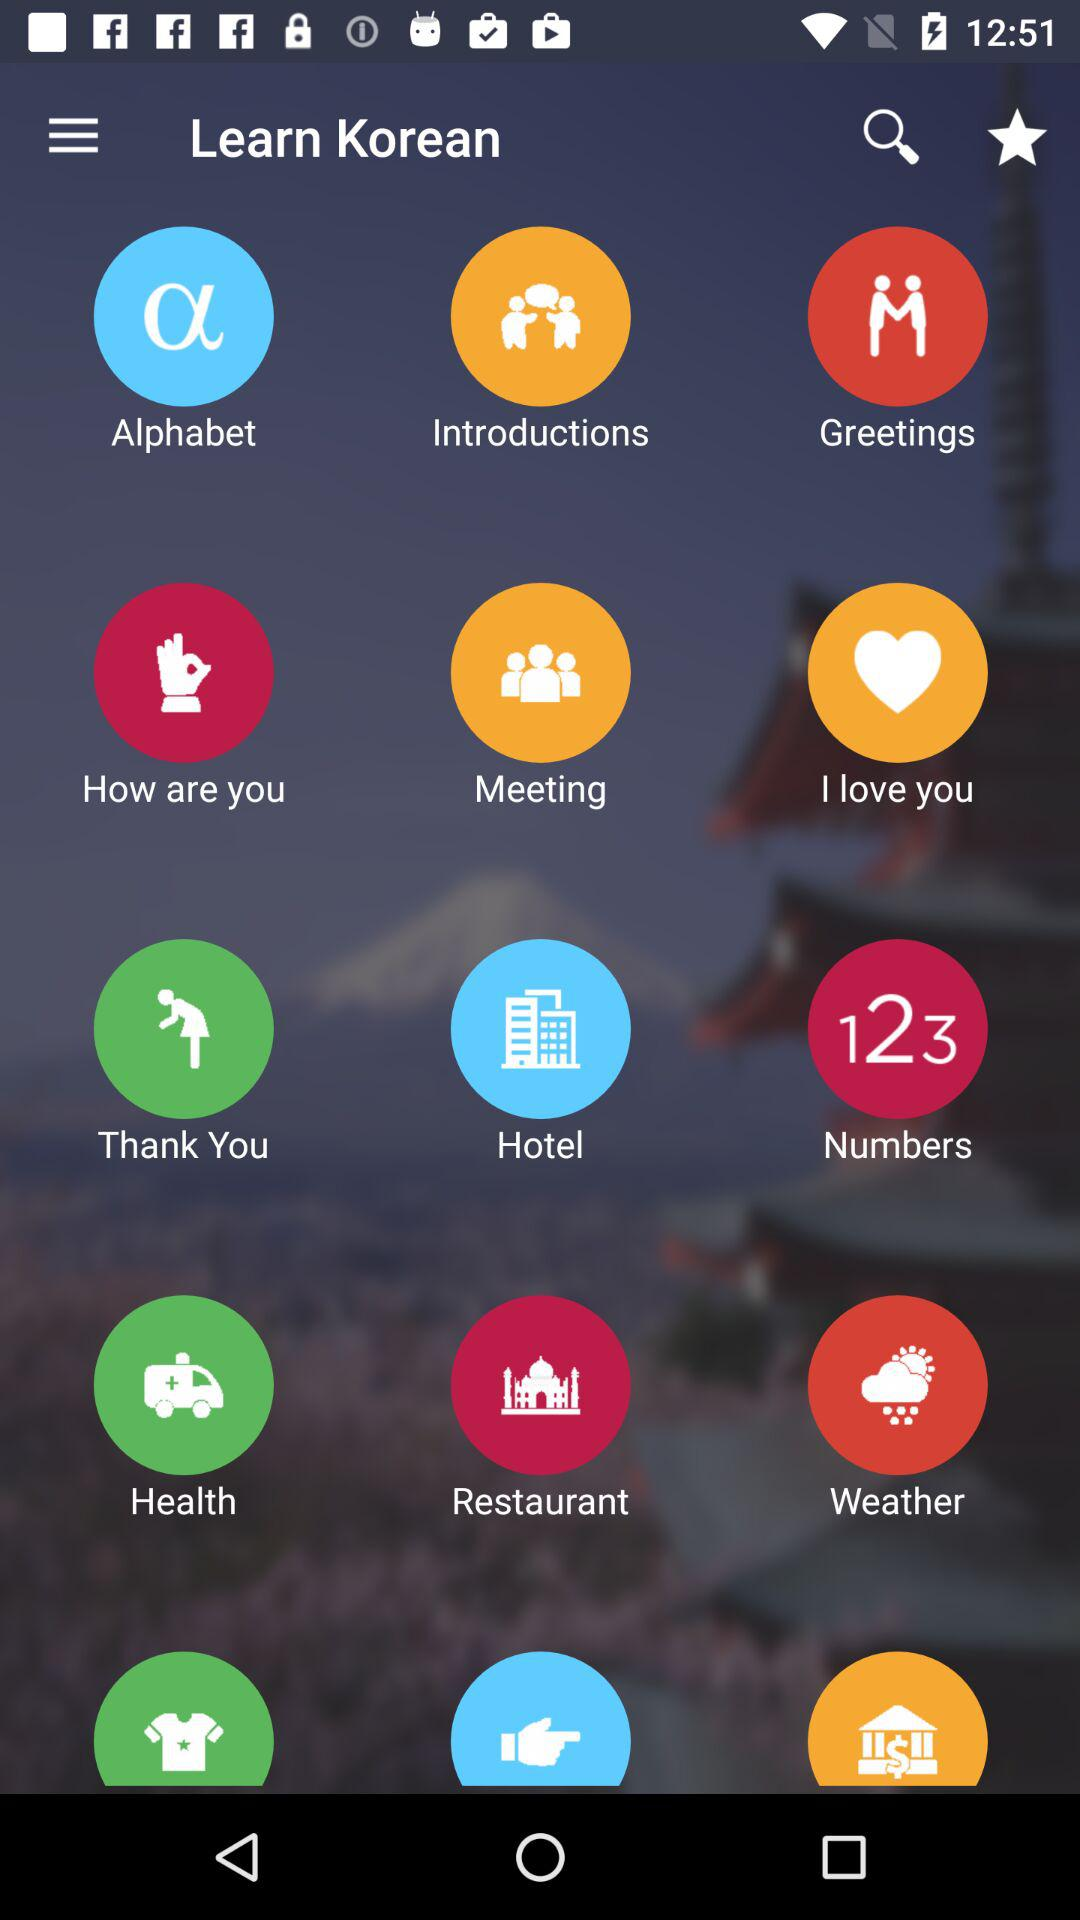What is the name of the application? The name of the application is "Learn Korean". 